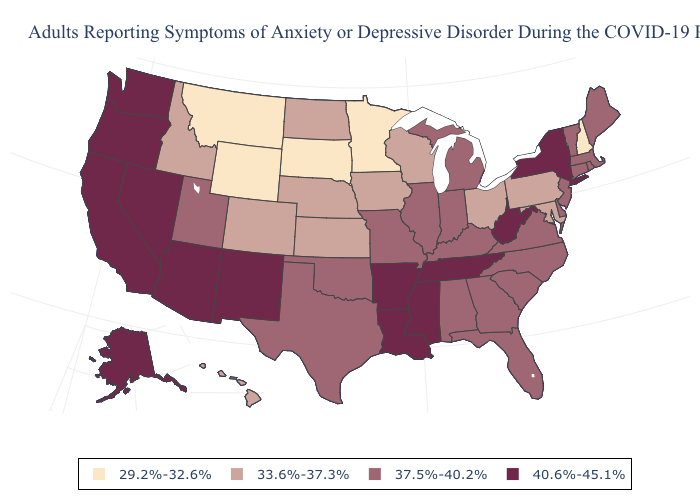Which states have the highest value in the USA?
Answer briefly. Alaska, Arizona, Arkansas, California, Louisiana, Mississippi, Nevada, New Mexico, New York, Oregon, Tennessee, Washington, West Virginia. What is the value of Vermont?
Keep it brief. 37.5%-40.2%. Does Nebraska have the highest value in the MidWest?
Concise answer only. No. Among the states that border Nevada , does Arizona have the lowest value?
Concise answer only. No. What is the highest value in the Northeast ?
Answer briefly. 40.6%-45.1%. Is the legend a continuous bar?
Give a very brief answer. No. Name the states that have a value in the range 33.6%-37.3%?
Keep it brief. Colorado, Hawaii, Idaho, Iowa, Kansas, Maryland, Nebraska, North Dakota, Ohio, Pennsylvania, Wisconsin. Name the states that have a value in the range 29.2%-32.6%?
Quick response, please. Minnesota, Montana, New Hampshire, South Dakota, Wyoming. What is the highest value in the USA?
Give a very brief answer. 40.6%-45.1%. Among the states that border North Carolina , which have the highest value?
Keep it brief. Tennessee. What is the value of Mississippi?
Answer briefly. 40.6%-45.1%. Does West Virginia have the lowest value in the USA?
Write a very short answer. No. What is the value of Illinois?
Concise answer only. 37.5%-40.2%. What is the value of South Dakota?
Answer briefly. 29.2%-32.6%. What is the value of Delaware?
Keep it brief. 37.5%-40.2%. 